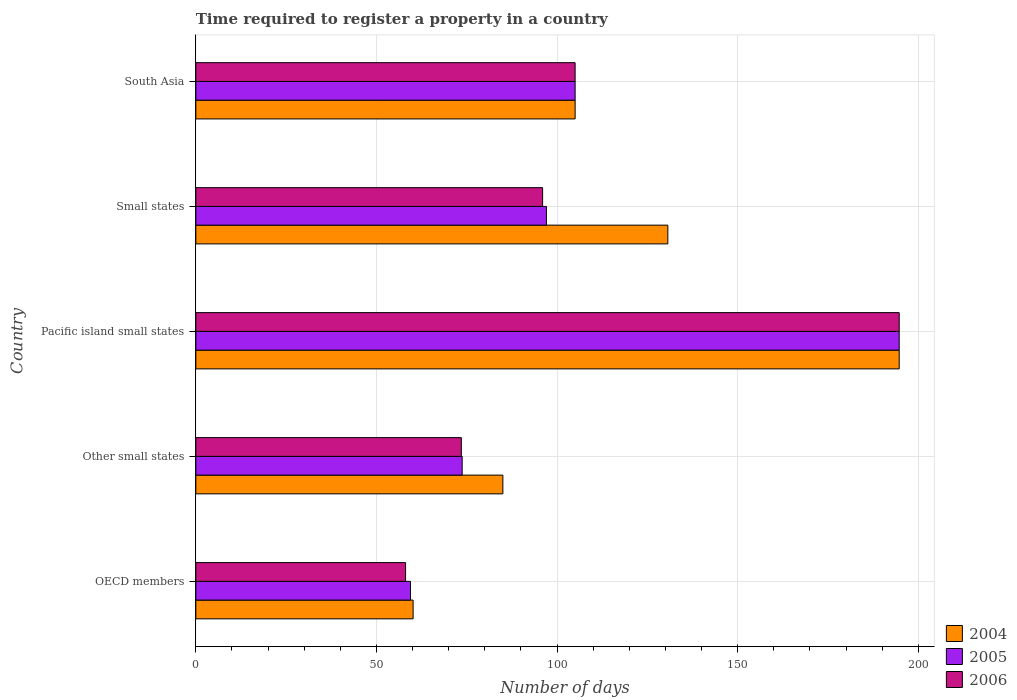How many different coloured bars are there?
Offer a very short reply. 3. How many groups of bars are there?
Your answer should be compact. 5. Are the number of bars per tick equal to the number of legend labels?
Offer a terse response. Yes. Are the number of bars on each tick of the Y-axis equal?
Make the answer very short. Yes. How many bars are there on the 4th tick from the top?
Make the answer very short. 3. What is the label of the 5th group of bars from the top?
Keep it short and to the point. OECD members. In how many cases, is the number of bars for a given country not equal to the number of legend labels?
Your answer should be compact. 0. What is the number of days required to register a property in 2005 in Small states?
Offer a very short reply. 97.06. Across all countries, what is the maximum number of days required to register a property in 2005?
Ensure brevity in your answer.  194.71. Across all countries, what is the minimum number of days required to register a property in 2006?
Ensure brevity in your answer.  58.06. In which country was the number of days required to register a property in 2004 maximum?
Your response must be concise. Pacific island small states. What is the total number of days required to register a property in 2004 in the graph?
Offer a very short reply. 575.53. What is the difference between the number of days required to register a property in 2006 in Pacific island small states and that in South Asia?
Keep it short and to the point. 89.71. What is the difference between the number of days required to register a property in 2006 in Small states and the number of days required to register a property in 2004 in OECD members?
Provide a succinct answer. 35.85. What is the average number of days required to register a property in 2006 per country?
Keep it short and to the point. 105.46. What is the difference between the number of days required to register a property in 2005 and number of days required to register a property in 2006 in Other small states?
Keep it short and to the point. 0.23. What is the ratio of the number of days required to register a property in 2005 in Pacific island small states to that in South Asia?
Ensure brevity in your answer.  1.85. Is the number of days required to register a property in 2004 in OECD members less than that in Pacific island small states?
Provide a succinct answer. Yes. What is the difference between the highest and the second highest number of days required to register a property in 2004?
Make the answer very short. 64.05. What is the difference between the highest and the lowest number of days required to register a property in 2005?
Offer a terse response. 135.28. Is the sum of the number of days required to register a property in 2005 in OECD members and Pacific island small states greater than the maximum number of days required to register a property in 2004 across all countries?
Your answer should be very brief. Yes. What does the 3rd bar from the bottom in OECD members represents?
Your answer should be compact. 2006. Is it the case that in every country, the sum of the number of days required to register a property in 2005 and number of days required to register a property in 2006 is greater than the number of days required to register a property in 2004?
Your response must be concise. Yes. How many bars are there?
Your answer should be very brief. 15. What is the difference between two consecutive major ticks on the X-axis?
Your answer should be very brief. 50. Does the graph contain any zero values?
Give a very brief answer. No. Does the graph contain grids?
Offer a very short reply. Yes. How many legend labels are there?
Offer a terse response. 3. How are the legend labels stacked?
Your response must be concise. Vertical. What is the title of the graph?
Offer a very short reply. Time required to register a property in a country. What is the label or title of the X-axis?
Offer a very short reply. Number of days. What is the label or title of the Y-axis?
Your response must be concise. Country. What is the Number of days in 2004 in OECD members?
Provide a short and direct response. 60.15. What is the Number of days in 2005 in OECD members?
Your answer should be compact. 59.43. What is the Number of days in 2006 in OECD members?
Your answer should be compact. 58.06. What is the Number of days in 2004 in Other small states?
Your answer should be compact. 85. What is the Number of days of 2005 in Other small states?
Your answer should be very brief. 73.73. What is the Number of days of 2006 in Other small states?
Provide a short and direct response. 73.5. What is the Number of days in 2004 in Pacific island small states?
Your answer should be compact. 194.71. What is the Number of days of 2005 in Pacific island small states?
Offer a very short reply. 194.71. What is the Number of days in 2006 in Pacific island small states?
Keep it short and to the point. 194.71. What is the Number of days in 2004 in Small states?
Your answer should be very brief. 130.67. What is the Number of days in 2005 in Small states?
Give a very brief answer. 97.06. What is the Number of days in 2006 in Small states?
Your answer should be compact. 96. What is the Number of days of 2004 in South Asia?
Offer a very short reply. 105. What is the Number of days of 2005 in South Asia?
Your answer should be very brief. 105. What is the Number of days of 2006 in South Asia?
Ensure brevity in your answer.  105. Across all countries, what is the maximum Number of days of 2004?
Give a very brief answer. 194.71. Across all countries, what is the maximum Number of days of 2005?
Make the answer very short. 194.71. Across all countries, what is the maximum Number of days in 2006?
Offer a very short reply. 194.71. Across all countries, what is the minimum Number of days in 2004?
Ensure brevity in your answer.  60.15. Across all countries, what is the minimum Number of days of 2005?
Offer a terse response. 59.43. Across all countries, what is the minimum Number of days in 2006?
Keep it short and to the point. 58.06. What is the total Number of days in 2004 in the graph?
Your answer should be compact. 575.53. What is the total Number of days in 2005 in the graph?
Your answer should be very brief. 529.94. What is the total Number of days in 2006 in the graph?
Offer a very short reply. 527.28. What is the difference between the Number of days in 2004 in OECD members and that in Other small states?
Your answer should be very brief. -24.85. What is the difference between the Number of days of 2005 in OECD members and that in Other small states?
Your answer should be compact. -14.3. What is the difference between the Number of days of 2006 in OECD members and that in Other small states?
Keep it short and to the point. -15.44. What is the difference between the Number of days of 2004 in OECD members and that in Pacific island small states?
Keep it short and to the point. -134.56. What is the difference between the Number of days in 2005 in OECD members and that in Pacific island small states?
Your response must be concise. -135.28. What is the difference between the Number of days of 2006 in OECD members and that in Pacific island small states?
Provide a short and direct response. -136.65. What is the difference between the Number of days in 2004 in OECD members and that in Small states?
Provide a short and direct response. -70.52. What is the difference between the Number of days of 2005 in OECD members and that in Small states?
Your answer should be compact. -37.63. What is the difference between the Number of days of 2006 in OECD members and that in Small states?
Keep it short and to the point. -37.94. What is the difference between the Number of days of 2004 in OECD members and that in South Asia?
Make the answer very short. -44.85. What is the difference between the Number of days of 2005 in OECD members and that in South Asia?
Keep it short and to the point. -45.57. What is the difference between the Number of days of 2006 in OECD members and that in South Asia?
Your answer should be compact. -46.94. What is the difference between the Number of days in 2004 in Other small states and that in Pacific island small states?
Your answer should be very brief. -109.71. What is the difference between the Number of days in 2005 in Other small states and that in Pacific island small states?
Keep it short and to the point. -120.98. What is the difference between the Number of days in 2006 in Other small states and that in Pacific island small states?
Offer a very short reply. -121.21. What is the difference between the Number of days in 2004 in Other small states and that in Small states?
Your response must be concise. -45.67. What is the difference between the Number of days of 2005 in Other small states and that in Small states?
Make the answer very short. -23.33. What is the difference between the Number of days of 2006 in Other small states and that in Small states?
Ensure brevity in your answer.  -22.5. What is the difference between the Number of days in 2004 in Other small states and that in South Asia?
Make the answer very short. -20. What is the difference between the Number of days of 2005 in Other small states and that in South Asia?
Offer a terse response. -31.27. What is the difference between the Number of days in 2006 in Other small states and that in South Asia?
Your response must be concise. -31.5. What is the difference between the Number of days in 2004 in Pacific island small states and that in Small states?
Make the answer very short. 64.05. What is the difference between the Number of days in 2005 in Pacific island small states and that in Small states?
Provide a succinct answer. 97.65. What is the difference between the Number of days in 2006 in Pacific island small states and that in Small states?
Ensure brevity in your answer.  98.71. What is the difference between the Number of days of 2004 in Pacific island small states and that in South Asia?
Provide a short and direct response. 89.71. What is the difference between the Number of days of 2005 in Pacific island small states and that in South Asia?
Offer a terse response. 89.71. What is the difference between the Number of days in 2006 in Pacific island small states and that in South Asia?
Offer a terse response. 89.71. What is the difference between the Number of days in 2004 in Small states and that in South Asia?
Offer a very short reply. 25.67. What is the difference between the Number of days of 2005 in Small states and that in South Asia?
Provide a short and direct response. -7.94. What is the difference between the Number of days in 2004 in OECD members and the Number of days in 2005 in Other small states?
Offer a very short reply. -13.58. What is the difference between the Number of days of 2004 in OECD members and the Number of days of 2006 in Other small states?
Your answer should be very brief. -13.35. What is the difference between the Number of days of 2005 in OECD members and the Number of days of 2006 in Other small states?
Your response must be concise. -14.07. What is the difference between the Number of days in 2004 in OECD members and the Number of days in 2005 in Pacific island small states?
Ensure brevity in your answer.  -134.56. What is the difference between the Number of days of 2004 in OECD members and the Number of days of 2006 in Pacific island small states?
Offer a terse response. -134.56. What is the difference between the Number of days in 2005 in OECD members and the Number of days in 2006 in Pacific island small states?
Provide a short and direct response. -135.28. What is the difference between the Number of days of 2004 in OECD members and the Number of days of 2005 in Small states?
Offer a very short reply. -36.91. What is the difference between the Number of days of 2004 in OECD members and the Number of days of 2006 in Small states?
Your answer should be very brief. -35.85. What is the difference between the Number of days of 2005 in OECD members and the Number of days of 2006 in Small states?
Offer a very short reply. -36.57. What is the difference between the Number of days in 2004 in OECD members and the Number of days in 2005 in South Asia?
Your answer should be compact. -44.85. What is the difference between the Number of days of 2004 in OECD members and the Number of days of 2006 in South Asia?
Offer a very short reply. -44.85. What is the difference between the Number of days in 2005 in OECD members and the Number of days in 2006 in South Asia?
Your answer should be very brief. -45.57. What is the difference between the Number of days in 2004 in Other small states and the Number of days in 2005 in Pacific island small states?
Provide a succinct answer. -109.71. What is the difference between the Number of days in 2004 in Other small states and the Number of days in 2006 in Pacific island small states?
Ensure brevity in your answer.  -109.71. What is the difference between the Number of days of 2005 in Other small states and the Number of days of 2006 in Pacific island small states?
Provide a succinct answer. -120.98. What is the difference between the Number of days of 2004 in Other small states and the Number of days of 2005 in Small states?
Your response must be concise. -12.06. What is the difference between the Number of days of 2004 in Other small states and the Number of days of 2006 in Small states?
Offer a very short reply. -11. What is the difference between the Number of days in 2005 in Other small states and the Number of days in 2006 in Small states?
Keep it short and to the point. -22.27. What is the difference between the Number of days of 2004 in Other small states and the Number of days of 2006 in South Asia?
Your answer should be very brief. -20. What is the difference between the Number of days of 2005 in Other small states and the Number of days of 2006 in South Asia?
Your answer should be very brief. -31.27. What is the difference between the Number of days in 2004 in Pacific island small states and the Number of days in 2005 in Small states?
Make the answer very short. 97.65. What is the difference between the Number of days of 2004 in Pacific island small states and the Number of days of 2006 in Small states?
Make the answer very short. 98.71. What is the difference between the Number of days of 2005 in Pacific island small states and the Number of days of 2006 in Small states?
Provide a succinct answer. 98.71. What is the difference between the Number of days in 2004 in Pacific island small states and the Number of days in 2005 in South Asia?
Offer a very short reply. 89.71. What is the difference between the Number of days in 2004 in Pacific island small states and the Number of days in 2006 in South Asia?
Keep it short and to the point. 89.71. What is the difference between the Number of days of 2005 in Pacific island small states and the Number of days of 2006 in South Asia?
Provide a succinct answer. 89.71. What is the difference between the Number of days in 2004 in Small states and the Number of days in 2005 in South Asia?
Make the answer very short. 25.67. What is the difference between the Number of days of 2004 in Small states and the Number of days of 2006 in South Asia?
Offer a terse response. 25.67. What is the difference between the Number of days in 2005 in Small states and the Number of days in 2006 in South Asia?
Provide a short and direct response. -7.94. What is the average Number of days of 2004 per country?
Keep it short and to the point. 115.11. What is the average Number of days of 2005 per country?
Keep it short and to the point. 105.99. What is the average Number of days of 2006 per country?
Your answer should be very brief. 105.46. What is the difference between the Number of days of 2004 and Number of days of 2005 in OECD members?
Give a very brief answer. 0.72. What is the difference between the Number of days of 2004 and Number of days of 2006 in OECD members?
Your response must be concise. 2.09. What is the difference between the Number of days in 2005 and Number of days in 2006 in OECD members?
Give a very brief answer. 1.37. What is the difference between the Number of days in 2004 and Number of days in 2005 in Other small states?
Keep it short and to the point. 11.27. What is the difference between the Number of days of 2005 and Number of days of 2006 in Other small states?
Provide a short and direct response. 0.23. What is the difference between the Number of days in 2004 and Number of days in 2005 in Pacific island small states?
Your answer should be very brief. 0. What is the difference between the Number of days of 2004 and Number of days of 2006 in Pacific island small states?
Offer a very short reply. 0. What is the difference between the Number of days of 2004 and Number of days of 2005 in Small states?
Provide a short and direct response. 33.61. What is the difference between the Number of days of 2004 and Number of days of 2006 in Small states?
Offer a very short reply. 34.67. What is the difference between the Number of days in 2005 and Number of days in 2006 in Small states?
Keep it short and to the point. 1.06. What is the difference between the Number of days in 2005 and Number of days in 2006 in South Asia?
Ensure brevity in your answer.  0. What is the ratio of the Number of days of 2004 in OECD members to that in Other small states?
Offer a terse response. 0.71. What is the ratio of the Number of days of 2005 in OECD members to that in Other small states?
Provide a short and direct response. 0.81. What is the ratio of the Number of days of 2006 in OECD members to that in Other small states?
Give a very brief answer. 0.79. What is the ratio of the Number of days of 2004 in OECD members to that in Pacific island small states?
Provide a short and direct response. 0.31. What is the ratio of the Number of days of 2005 in OECD members to that in Pacific island small states?
Ensure brevity in your answer.  0.31. What is the ratio of the Number of days in 2006 in OECD members to that in Pacific island small states?
Give a very brief answer. 0.3. What is the ratio of the Number of days in 2004 in OECD members to that in Small states?
Make the answer very short. 0.46. What is the ratio of the Number of days of 2005 in OECD members to that in Small states?
Give a very brief answer. 0.61. What is the ratio of the Number of days in 2006 in OECD members to that in Small states?
Your answer should be very brief. 0.6. What is the ratio of the Number of days in 2004 in OECD members to that in South Asia?
Provide a short and direct response. 0.57. What is the ratio of the Number of days of 2005 in OECD members to that in South Asia?
Keep it short and to the point. 0.57. What is the ratio of the Number of days in 2006 in OECD members to that in South Asia?
Your response must be concise. 0.55. What is the ratio of the Number of days in 2004 in Other small states to that in Pacific island small states?
Make the answer very short. 0.44. What is the ratio of the Number of days in 2005 in Other small states to that in Pacific island small states?
Offer a very short reply. 0.38. What is the ratio of the Number of days in 2006 in Other small states to that in Pacific island small states?
Give a very brief answer. 0.38. What is the ratio of the Number of days of 2004 in Other small states to that in Small states?
Offer a very short reply. 0.65. What is the ratio of the Number of days in 2005 in Other small states to that in Small states?
Provide a succinct answer. 0.76. What is the ratio of the Number of days of 2006 in Other small states to that in Small states?
Keep it short and to the point. 0.77. What is the ratio of the Number of days of 2004 in Other small states to that in South Asia?
Provide a succinct answer. 0.81. What is the ratio of the Number of days of 2005 in Other small states to that in South Asia?
Keep it short and to the point. 0.7. What is the ratio of the Number of days of 2004 in Pacific island small states to that in Small states?
Offer a very short reply. 1.49. What is the ratio of the Number of days of 2005 in Pacific island small states to that in Small states?
Your answer should be compact. 2.01. What is the ratio of the Number of days of 2006 in Pacific island small states to that in Small states?
Ensure brevity in your answer.  2.03. What is the ratio of the Number of days in 2004 in Pacific island small states to that in South Asia?
Your answer should be compact. 1.85. What is the ratio of the Number of days of 2005 in Pacific island small states to that in South Asia?
Ensure brevity in your answer.  1.85. What is the ratio of the Number of days of 2006 in Pacific island small states to that in South Asia?
Your answer should be compact. 1.85. What is the ratio of the Number of days in 2004 in Small states to that in South Asia?
Make the answer very short. 1.24. What is the ratio of the Number of days in 2005 in Small states to that in South Asia?
Your answer should be compact. 0.92. What is the ratio of the Number of days in 2006 in Small states to that in South Asia?
Your response must be concise. 0.91. What is the difference between the highest and the second highest Number of days in 2004?
Give a very brief answer. 64.05. What is the difference between the highest and the second highest Number of days of 2005?
Your response must be concise. 89.71. What is the difference between the highest and the second highest Number of days of 2006?
Keep it short and to the point. 89.71. What is the difference between the highest and the lowest Number of days in 2004?
Offer a very short reply. 134.56. What is the difference between the highest and the lowest Number of days in 2005?
Offer a very short reply. 135.28. What is the difference between the highest and the lowest Number of days of 2006?
Provide a succinct answer. 136.65. 